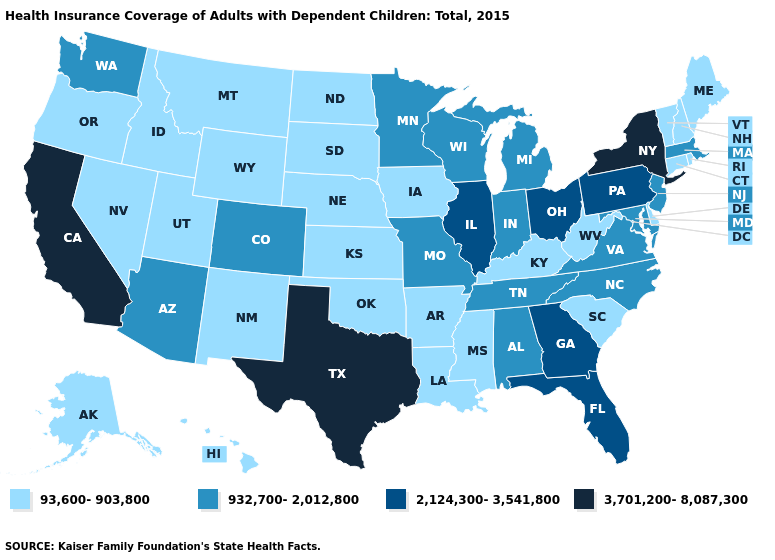Does Missouri have the highest value in the MidWest?
Answer briefly. No. What is the value of Missouri?
Keep it brief. 932,700-2,012,800. Does New Jersey have a higher value than Utah?
Answer briefly. Yes. How many symbols are there in the legend?
Give a very brief answer. 4. What is the value of Iowa?
Keep it brief. 93,600-903,800. What is the highest value in the West ?
Concise answer only. 3,701,200-8,087,300. Name the states that have a value in the range 2,124,300-3,541,800?
Short answer required. Florida, Georgia, Illinois, Ohio, Pennsylvania. What is the value of Michigan?
Concise answer only. 932,700-2,012,800. How many symbols are there in the legend?
Answer briefly. 4. Does North Carolina have the highest value in the USA?
Concise answer only. No. What is the value of Michigan?
Write a very short answer. 932,700-2,012,800. Does Illinois have the same value as North Dakota?
Be succinct. No. Does the map have missing data?
Quick response, please. No. What is the value of Iowa?
Concise answer only. 93,600-903,800. Does the first symbol in the legend represent the smallest category?
Write a very short answer. Yes. 